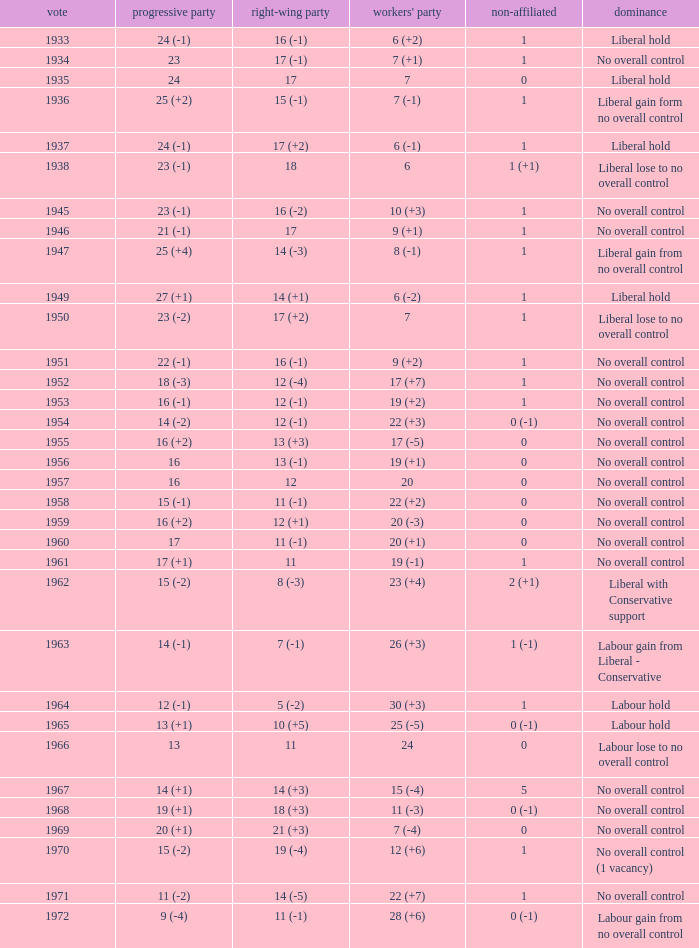Who was in control the year that Labour Party won 12 (+6) seats? No overall control (1 vacancy). 